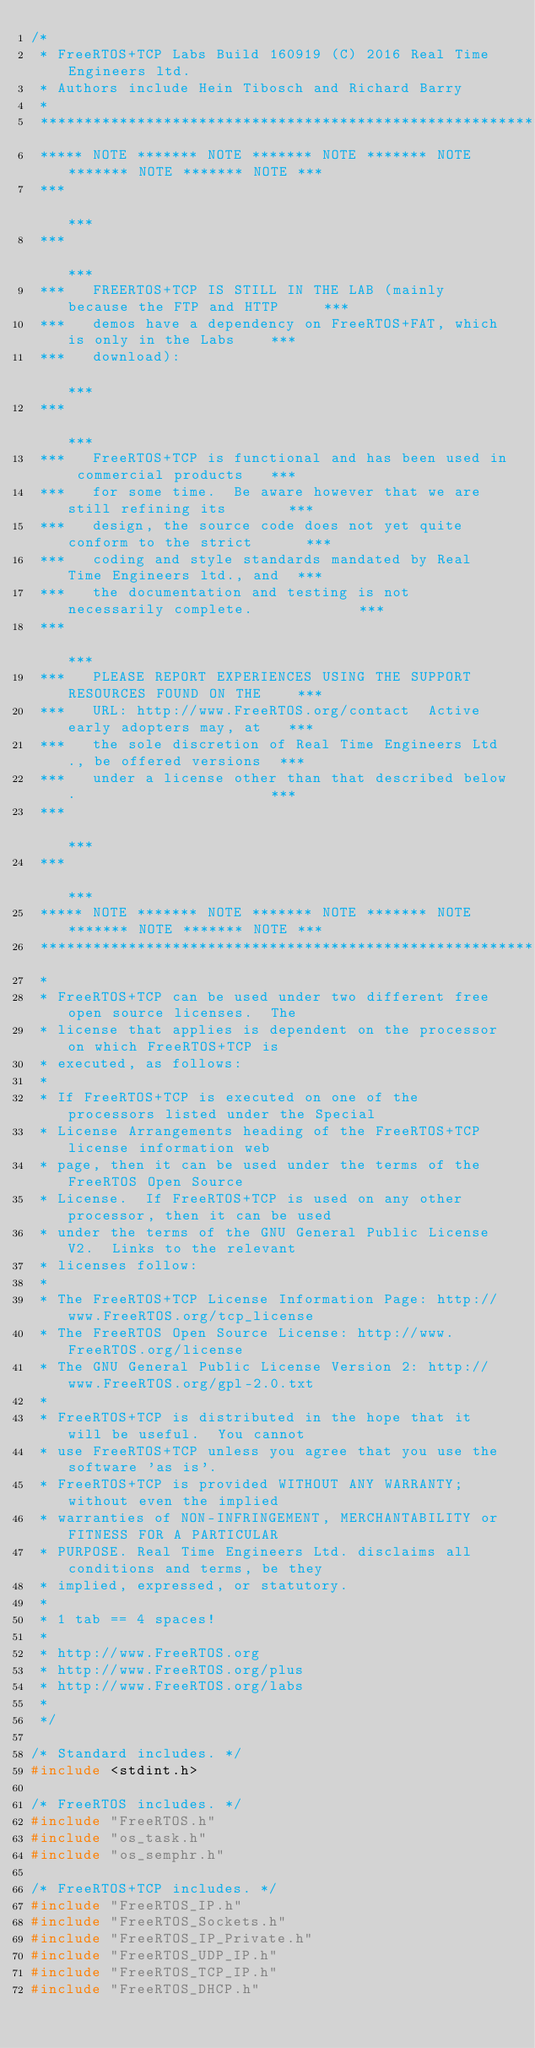Convert code to text. <code><loc_0><loc_0><loc_500><loc_500><_C_>/*
 * FreeRTOS+TCP Labs Build 160919 (C) 2016 Real Time Engineers ltd.
 * Authors include Hein Tibosch and Richard Barry
 *
 *******************************************************************************
 ***** NOTE ******* NOTE ******* NOTE ******* NOTE ******* NOTE ******* NOTE ***
 ***                                                                         ***
 ***                                                                         ***
 ***   FREERTOS+TCP IS STILL IN THE LAB (mainly because the FTP and HTTP     ***
 ***   demos have a dependency on FreeRTOS+FAT, which is only in the Labs    ***
 ***   download):                                                            ***
 ***                                                                         ***
 ***   FreeRTOS+TCP is functional and has been used in commercial products   ***
 ***   for some time.  Be aware however that we are still refining its       ***
 ***   design, the source code does not yet quite conform to the strict      ***
 ***   coding and style standards mandated by Real Time Engineers ltd., and  ***
 ***   the documentation and testing is not necessarily complete.            ***
 ***                                                                         ***
 ***   PLEASE REPORT EXPERIENCES USING THE SUPPORT RESOURCES FOUND ON THE    ***
 ***   URL: http://www.FreeRTOS.org/contact  Active early adopters may, at   ***
 ***   the sole discretion of Real Time Engineers Ltd., be offered versions  ***
 ***   under a license other than that described below.                      ***
 ***                                                                         ***
 ***                                                                         ***
 ***** NOTE ******* NOTE ******* NOTE ******* NOTE ******* NOTE ******* NOTE ***
 *******************************************************************************
 *
 * FreeRTOS+TCP can be used under two different free open source licenses.  The
 * license that applies is dependent on the processor on which FreeRTOS+TCP is
 * executed, as follows:
 *
 * If FreeRTOS+TCP is executed on one of the processors listed under the Special
 * License Arrangements heading of the FreeRTOS+TCP license information web
 * page, then it can be used under the terms of the FreeRTOS Open Source
 * License.  If FreeRTOS+TCP is used on any other processor, then it can be used
 * under the terms of the GNU General Public License V2.  Links to the relevant
 * licenses follow:
 *
 * The FreeRTOS+TCP License Information Page: http://www.FreeRTOS.org/tcp_license
 * The FreeRTOS Open Source License: http://www.FreeRTOS.org/license
 * The GNU General Public License Version 2: http://www.FreeRTOS.org/gpl-2.0.txt
 *
 * FreeRTOS+TCP is distributed in the hope that it will be useful.  You cannot
 * use FreeRTOS+TCP unless you agree that you use the software 'as is'.
 * FreeRTOS+TCP is provided WITHOUT ANY WARRANTY; without even the implied
 * warranties of NON-INFRINGEMENT, MERCHANTABILITY or FITNESS FOR A PARTICULAR
 * PURPOSE. Real Time Engineers Ltd. disclaims all conditions and terms, be they
 * implied, expressed, or statutory.
 *
 * 1 tab == 4 spaces!
 *
 * http://www.FreeRTOS.org
 * http://www.FreeRTOS.org/plus
 * http://www.FreeRTOS.org/labs
 *
 */

/* Standard includes. */
#include <stdint.h>

/* FreeRTOS includes. */
#include "FreeRTOS.h"
#include "os_task.h"
#include "os_semphr.h"

/* FreeRTOS+TCP includes. */
#include "FreeRTOS_IP.h"
#include "FreeRTOS_Sockets.h"
#include "FreeRTOS_IP_Private.h"
#include "FreeRTOS_UDP_IP.h"
#include "FreeRTOS_TCP_IP.h"
#include "FreeRTOS_DHCP.h"</code> 